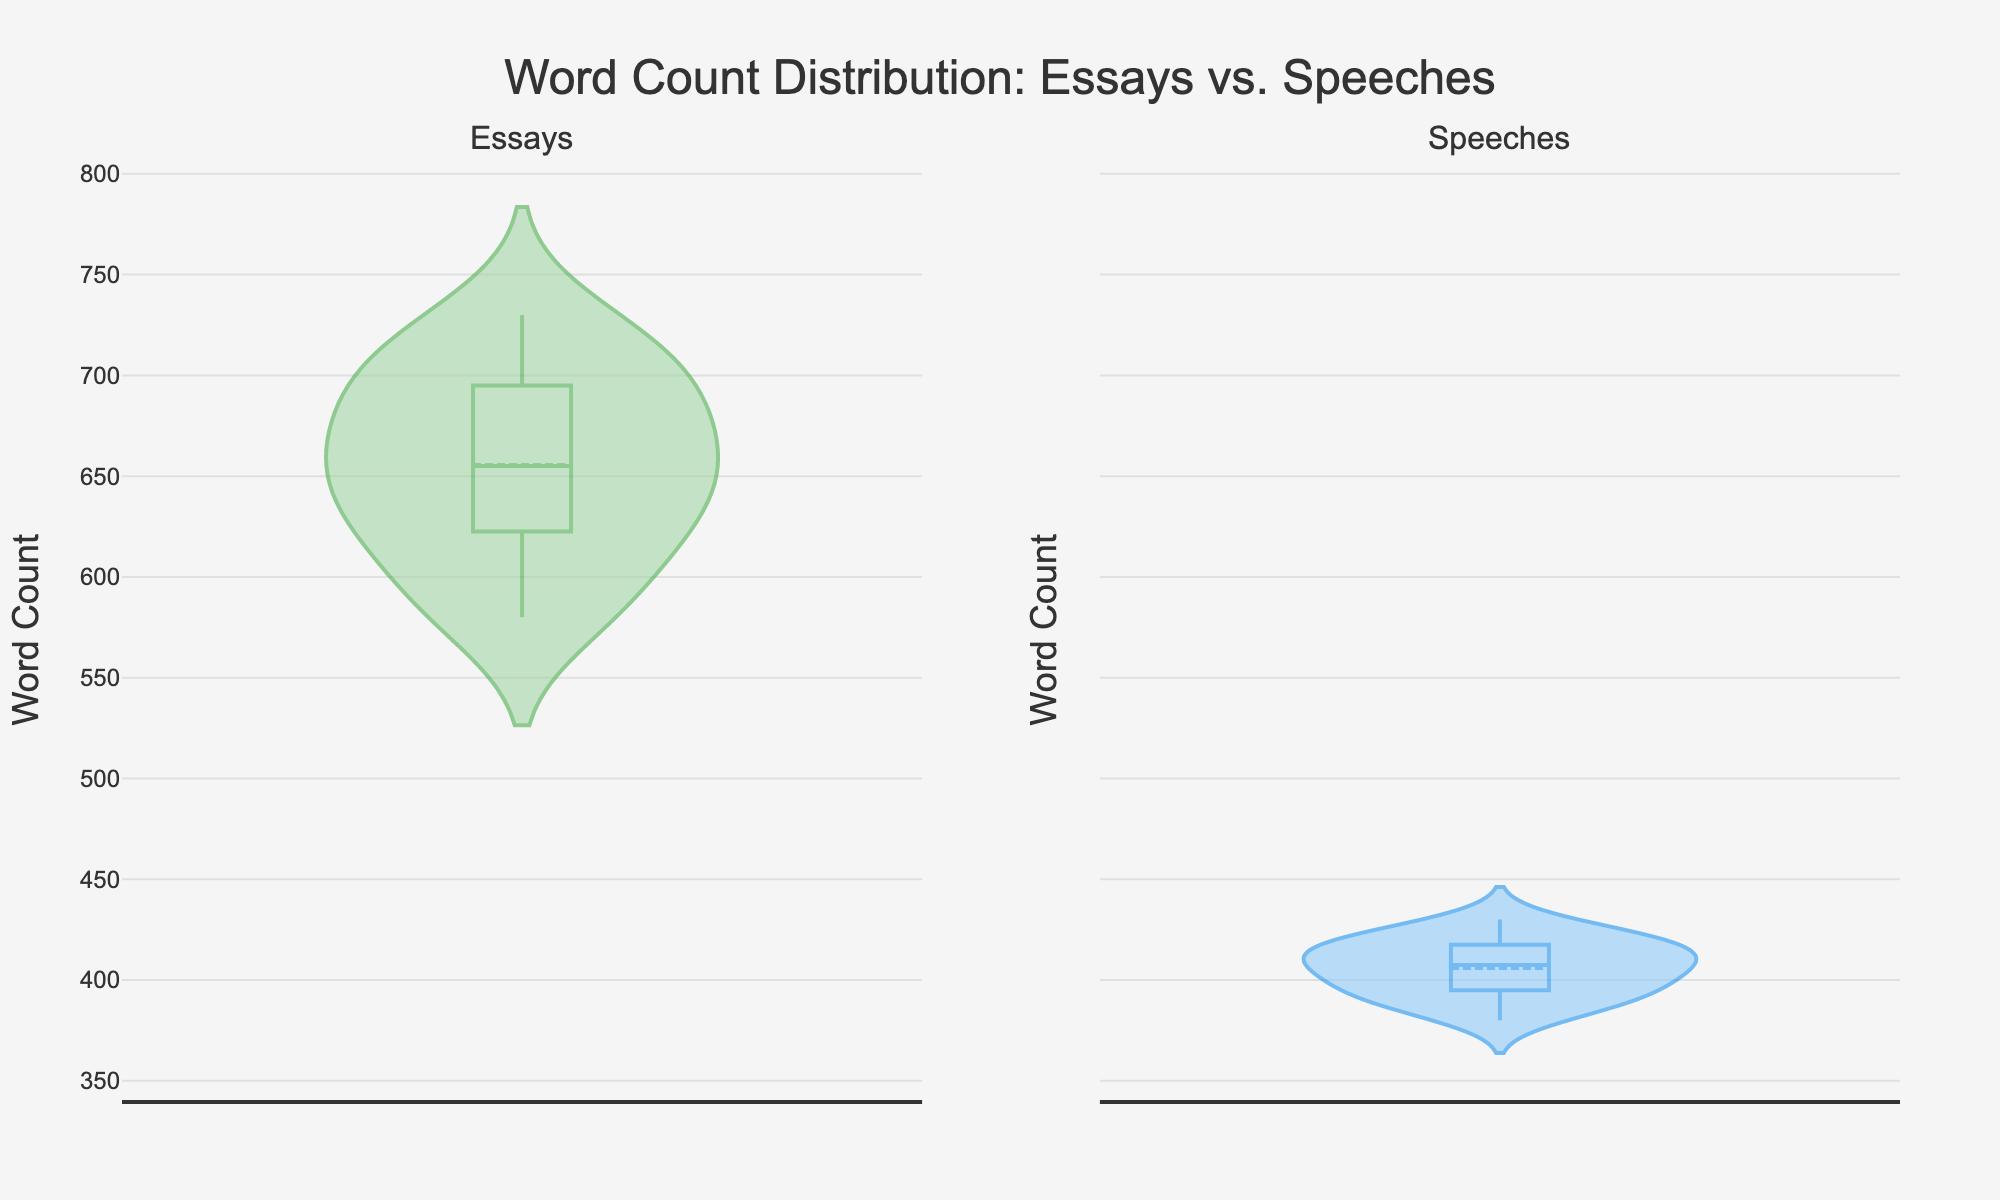What is the title of the figure? The title is located at the top of the figure and is usually the most prominent piece of text. In this case, it reads "Word Count Distribution: Essays vs. Speeches".
Answer: Word Count Distribution: Essays vs. Speeches How many different categories of data are shown in the figure? The figure has two subplots, each representing a different category of data. The titles of the subplots are "Essays" and "Speeches".
Answer: Two Which type of work appears to have a higher average word count, essays or speeches? The average word count can be estimated from where the thickest part of the violin plot is located. The essay plot appears to have its central tendency at a higher word count compared to the speech plot.
Answer: Essays What is the range of word counts for student essays? The range can be seen from the extent of the violin plot on the y-axis for essays. It stretches from around 580 to 730 words.
Answer: 580 to 730 words How does the word count distribution of speeches compare to that of essays? Observing the violin plots, the distribution for speeches is narrower and the central tendency is lower compared to essays. This means speeches generally have fewer words and less variation in word count than essays.
Answer: Narrower and lower Which category of work has greater variability in word count? Variability can be assessed by the width and spread of the violin plots. The essay plot is wider and more spread out than the speech plot, indicating greater variability.
Answer: Essays What are the minimum and maximum word counts observed in speeches? The minimum and maximum values are at the ends of the speech violin plot, which are around 380 words and 430 words, respectively.
Answer: 380 to 430 words Are there any notable differences in the central tendencies of the essays compared to speeches? The central tendency is shown by where the plot is most thick and dense, as well as the mean line. Essays have a higher central tendency at around 650 words, while speeches are around 405 words.
Answer: Yes, essays are higher Which subplot has more outliers, if any? Outliers are often represented by dots outside the main bulk of the violin plot. By examining the plots, essays have a few points outside the bulk, while speeches have fewer such points.
Answer: Essays What can be deduced about students' writing habits for essays versus speeches from this plot? Essays tend to be longer and show more variation in word counts, which might imply more flexibility or less stringent word count limits. Speeches, being shorter on average and less variable, might indicate stricter word limits and a different style of preparation.
Answer: Essays are longer and more varied, speeches are shorter and less varied 